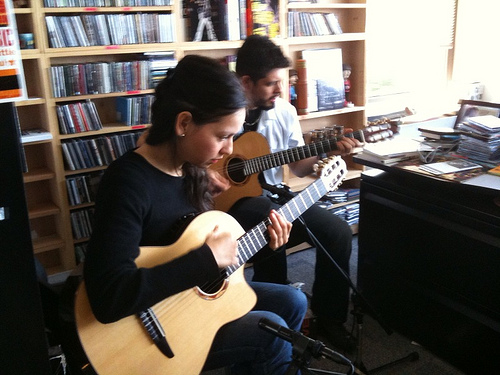<image>
Is there a guitar behind the table? Yes. From this viewpoint, the guitar is positioned behind the table, with the table partially or fully occluding the guitar. 